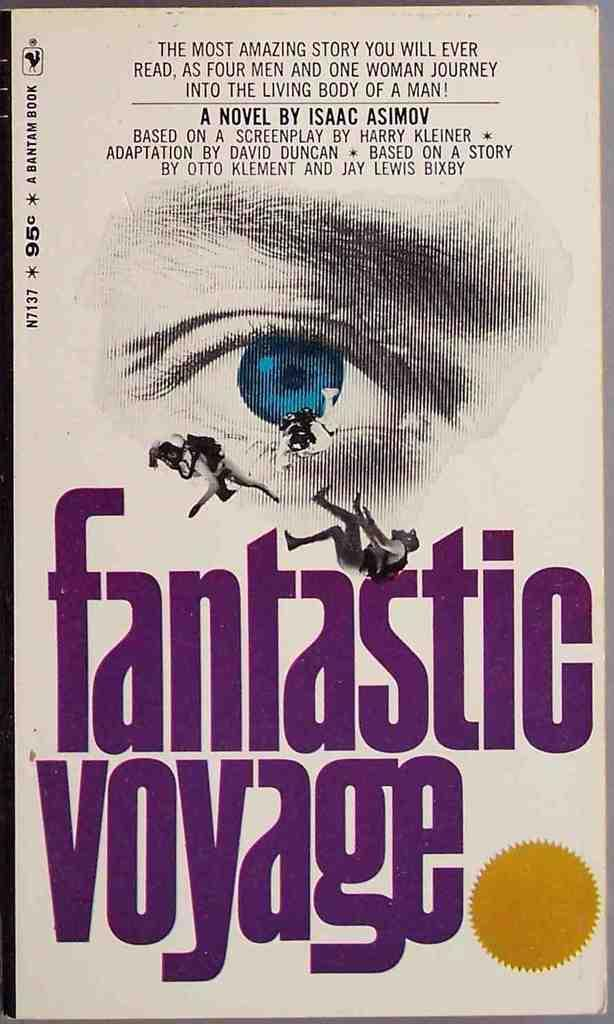Provide a one-sentence caption for the provided image. The cover of the Fantastic Voyage includes a close-up of a blue eye. 